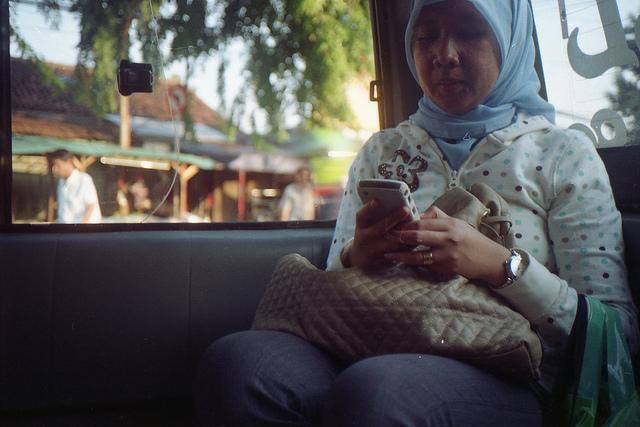What is one name for the type of headwear the woman is wearing?
Make your selection and explain in format: 'Answer: answer
Rationale: rationale.'
Options: Veil, cap, tie, hat. Answer: veil.
Rationale: The name is a veil. 